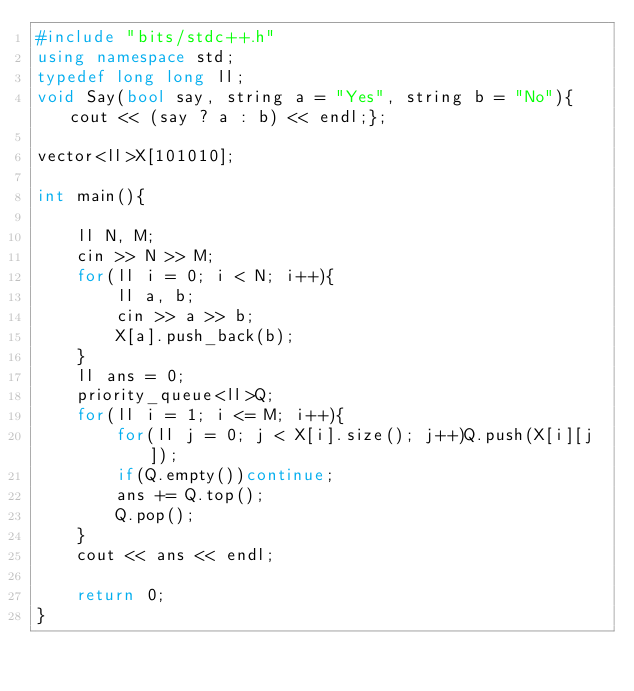Convert code to text. <code><loc_0><loc_0><loc_500><loc_500><_C++_>#include "bits/stdc++.h"
using namespace std;
typedef long long ll;
void Say(bool say, string a = "Yes", string b = "No"){cout << (say ? a : b) << endl;};

vector<ll>X[101010];

int main(){

    ll N, M;
    cin >> N >> M;
    for(ll i = 0; i < N; i++){
        ll a, b;
        cin >> a >> b;
        X[a].push_back(b);
    }
    ll ans = 0;
    priority_queue<ll>Q;
    for(ll i = 1; i <= M; i++){
        for(ll j = 0; j < X[i].size(); j++)Q.push(X[i][j]);
        if(Q.empty())continue;
        ans += Q.top();
        Q.pop();
    }
    cout << ans << endl;

    return 0;
}</code> 